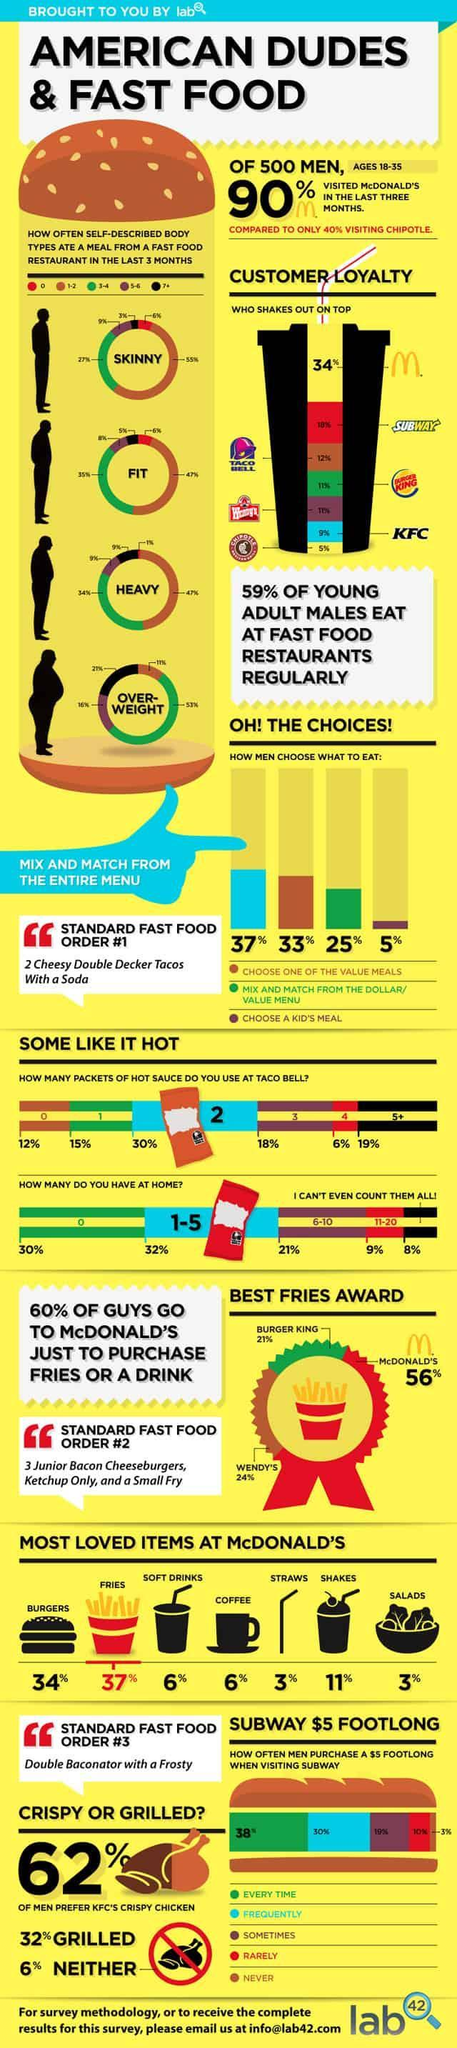What percentage of people do not store any hot sauce packets at home?
Answer the question with a short phrase. 30% What percentage of people use more than 5 hot sauce packets at Taco Bell? 19% How many meals did 47% the heavy body type have from a fast food restaurant? 1-2 What percentage of the fit body types ate 3-4 meals in last three months from a fast food? 35% Which two fast food chains have a share of 11% of customers loyalty? Burger King, Wendy's What percentage of men choose to mix and match from the menu? 37% What percentage of skinny body type eats 7 or more meals from a fast food restaurant in the last three months? 3% What is the percentage of women between 18 and 35 that visited McDonald's in last three months? 10% How many body types are listed here? 4 How many meals did 16%  overweight body type have from a fast food restaurants ? 5-6 